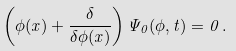Convert formula to latex. <formula><loc_0><loc_0><loc_500><loc_500>\left ( \phi ( { x } ) + \frac { \delta } { \delta \phi ( { x } ) } \right ) \Psi _ { 0 } ( \phi , t ) = 0 \, .</formula> 